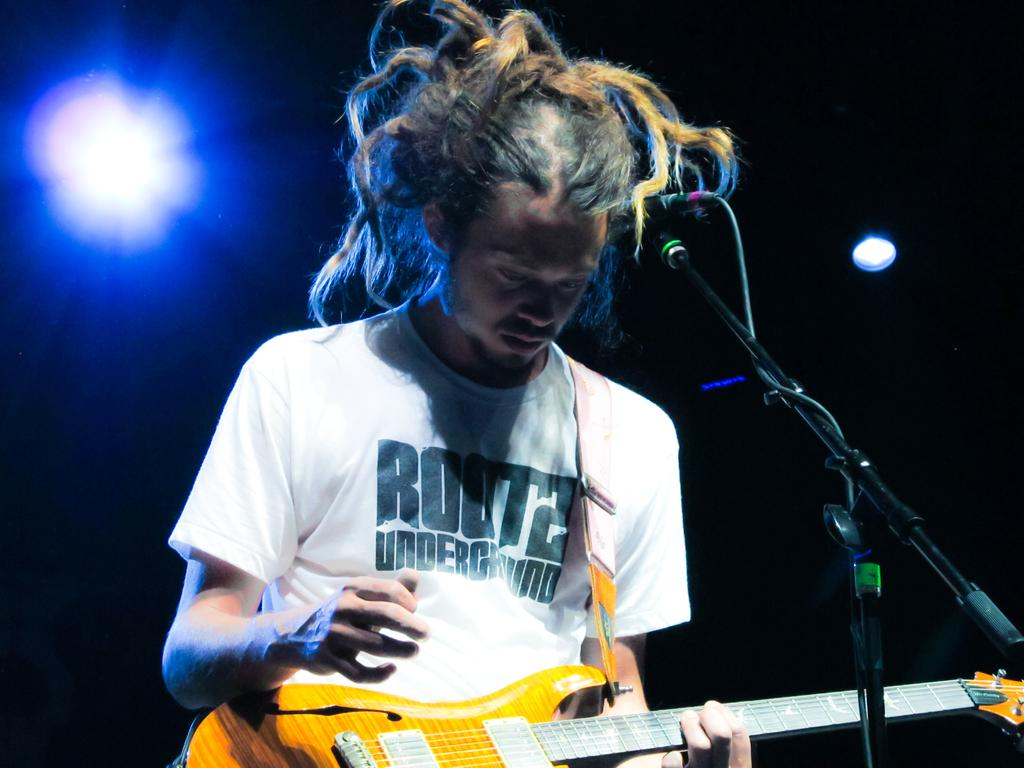Who is the person in the image? There is a man in the image. What is the man wearing? The man is wearing a white T-shirt. What is the man doing in the image? The man is playing a guitar. What equipment is present in the image for amplifying sound? There is a mike with a mike stand in the image. What type of lighting is visible in the image? There are show lights visible in the image. What is the weight of the pail in the image? There is no pail present in the image, so it is not possible to determine its weight. 